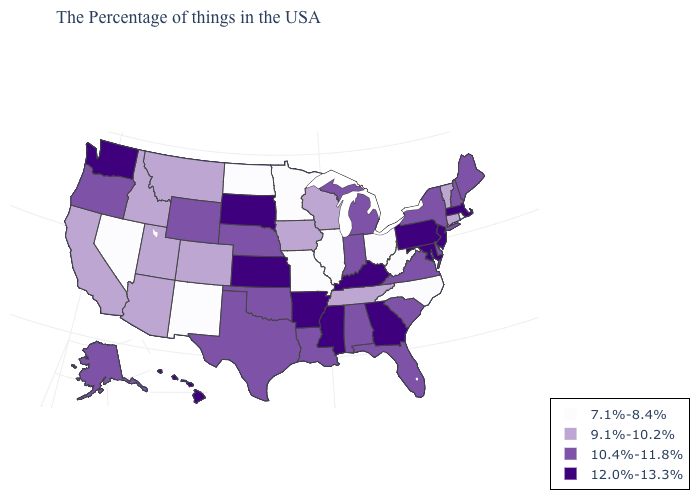What is the value of Pennsylvania?
Quick response, please. 12.0%-13.3%. What is the value of Alaska?
Concise answer only. 10.4%-11.8%. What is the value of Michigan?
Concise answer only. 10.4%-11.8%. Does Illinois have the highest value in the USA?
Give a very brief answer. No. Name the states that have a value in the range 9.1%-10.2%?
Concise answer only. Vermont, Connecticut, Tennessee, Wisconsin, Iowa, Colorado, Utah, Montana, Arizona, Idaho, California. What is the value of Vermont?
Concise answer only. 9.1%-10.2%. Name the states that have a value in the range 7.1%-8.4%?
Answer briefly. Rhode Island, North Carolina, West Virginia, Ohio, Illinois, Missouri, Minnesota, North Dakota, New Mexico, Nevada. What is the value of Indiana?
Give a very brief answer. 10.4%-11.8%. What is the value of Tennessee?
Be succinct. 9.1%-10.2%. Does Kentucky have the highest value in the South?
Give a very brief answer. Yes. What is the lowest value in the South?
Give a very brief answer. 7.1%-8.4%. What is the value of South Carolina?
Write a very short answer. 10.4%-11.8%. Name the states that have a value in the range 10.4%-11.8%?
Give a very brief answer. Maine, New Hampshire, New York, Delaware, Virginia, South Carolina, Florida, Michigan, Indiana, Alabama, Louisiana, Nebraska, Oklahoma, Texas, Wyoming, Oregon, Alaska. What is the value of Illinois?
Concise answer only. 7.1%-8.4%. 